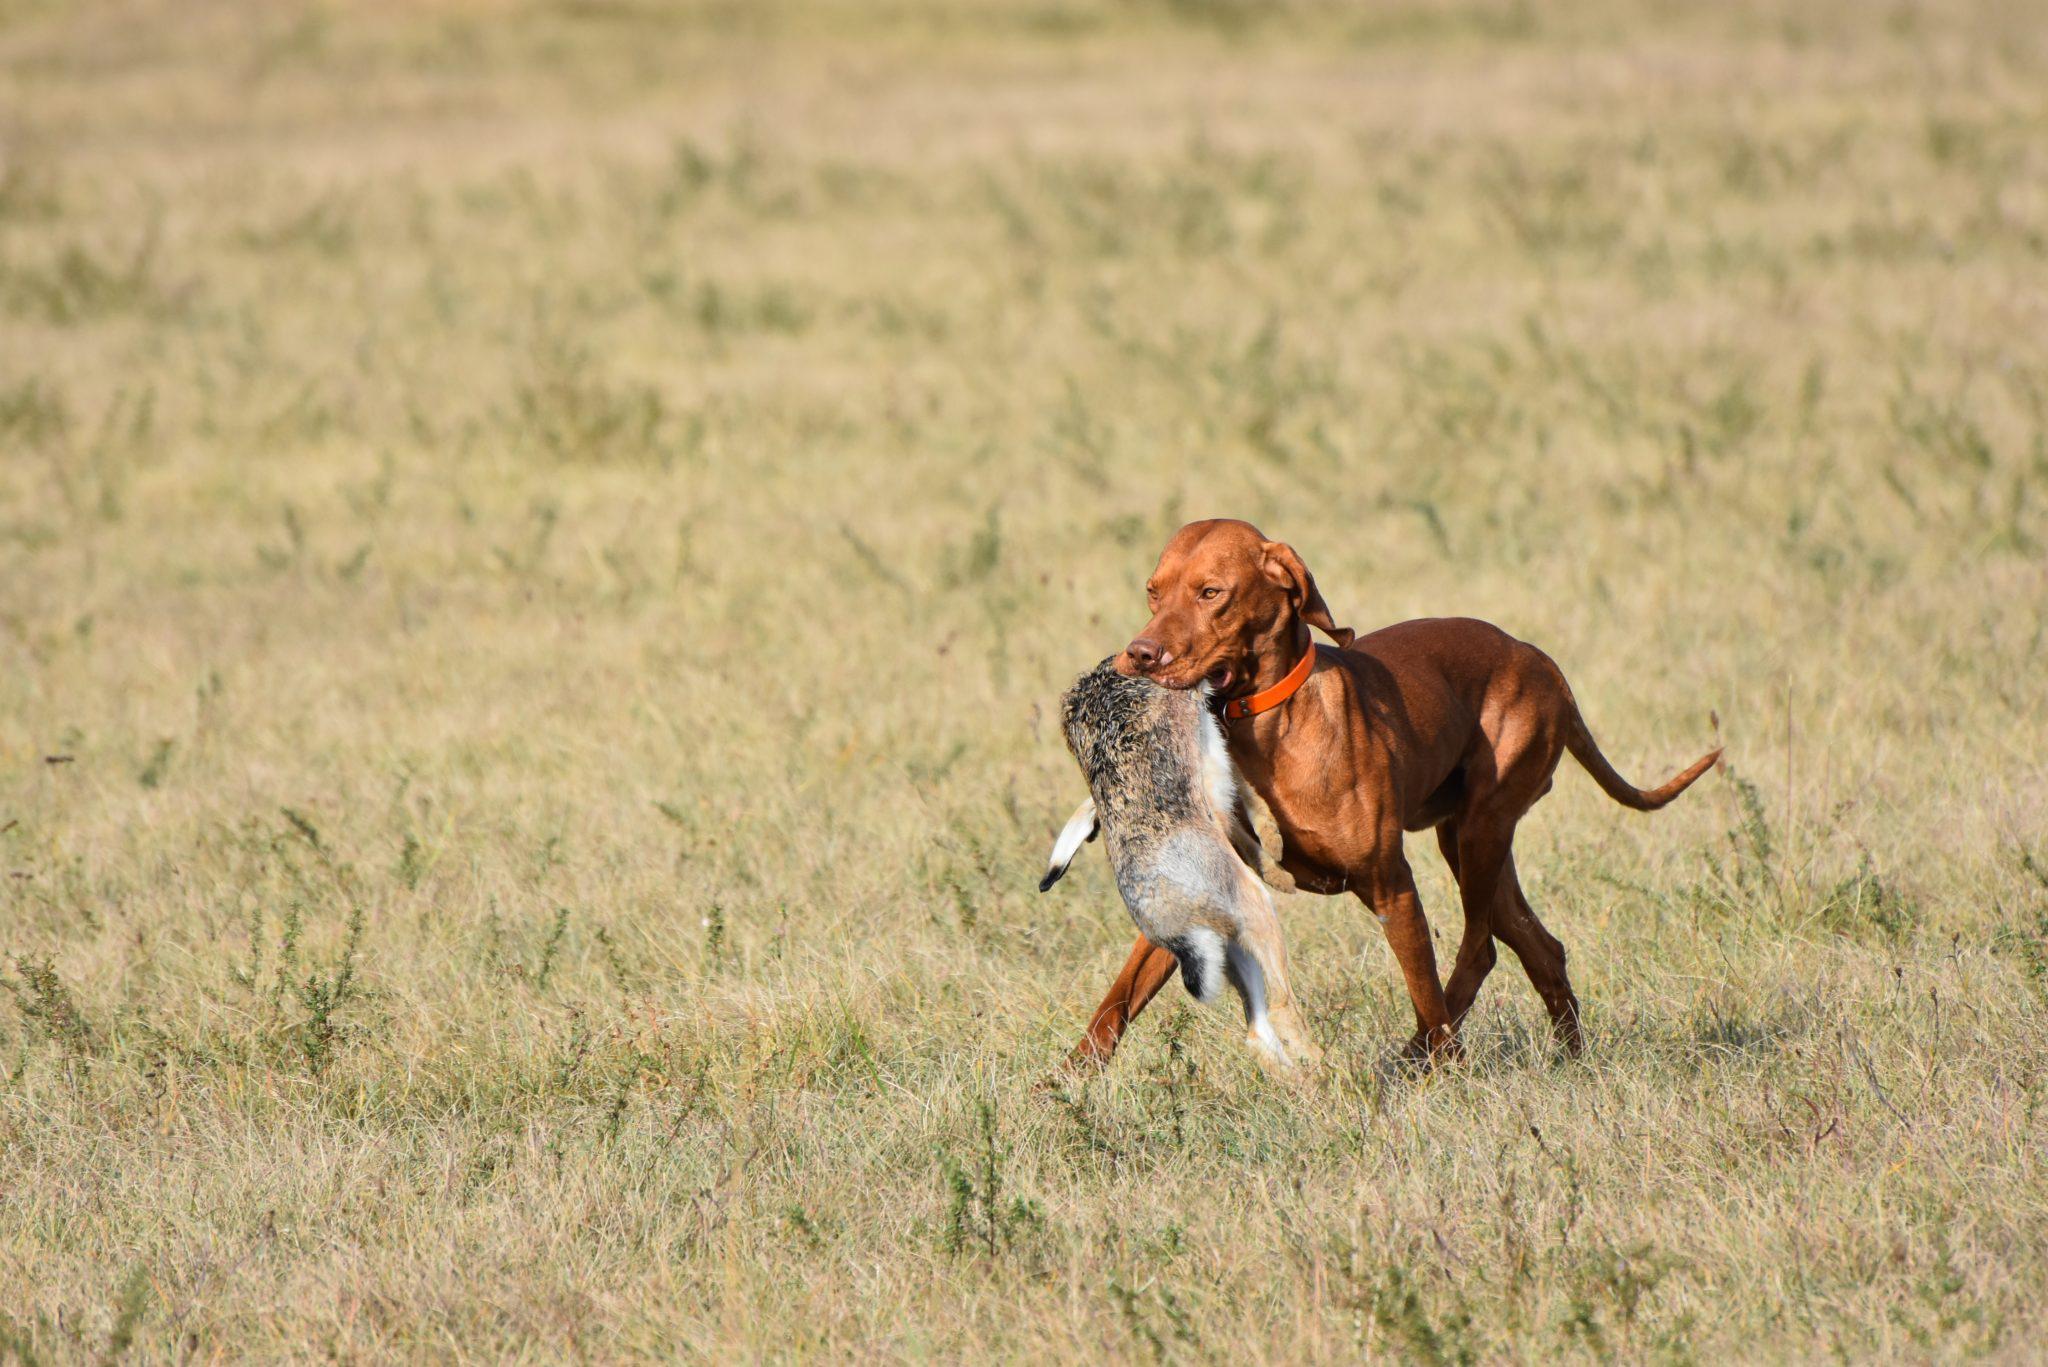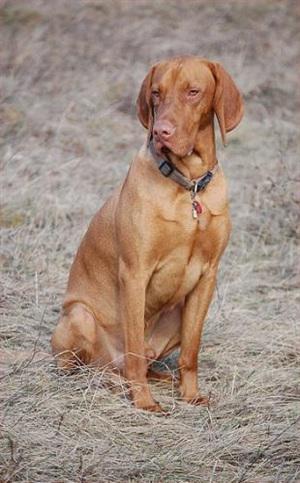The first image is the image on the left, the second image is the image on the right. Examine the images to the left and right. Is the description "The white motorbike has a dog passenger but no driver." accurate? Answer yes or no. No. The first image is the image on the left, the second image is the image on the right. Considering the images on both sides, is "The left image shows a red dog sitting in a white side car of a motorcycle without a driver on the seat." valid? Answer yes or no. No. 